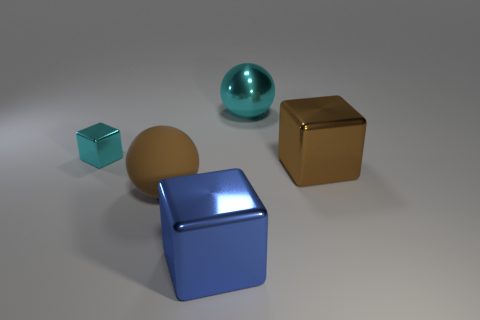Subtract all big blue cubes. How many cubes are left? 2 Add 1 tiny brown cylinders. How many objects exist? 6 Subtract all blocks. How many objects are left? 2 Add 5 cyan spheres. How many cyan spheres exist? 6 Subtract all brown blocks. How many blocks are left? 2 Subtract 0 red cubes. How many objects are left? 5 Subtract 2 spheres. How many spheres are left? 0 Subtract all cyan balls. Subtract all brown blocks. How many balls are left? 1 Subtract all yellow balls. How many blue cubes are left? 1 Subtract all big purple spheres. Subtract all large brown objects. How many objects are left? 3 